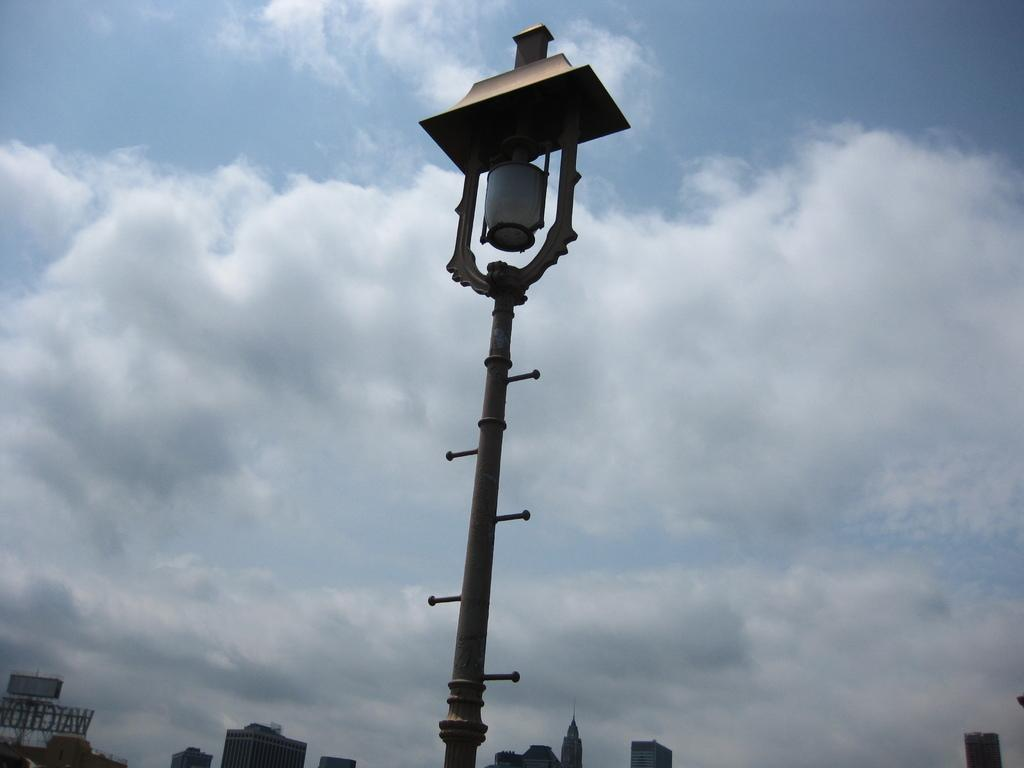What is the main object in the foreground of the image? There is a pole in the image. What can be seen in the distance behind the pole? There are buildings in the background of the image. How would you describe the sky in the image? The sky is cloudy in the background of the image. How does the paper control the movement of the pole in the image? There is no paper present in the image, and therefore no such interaction can be observed. 